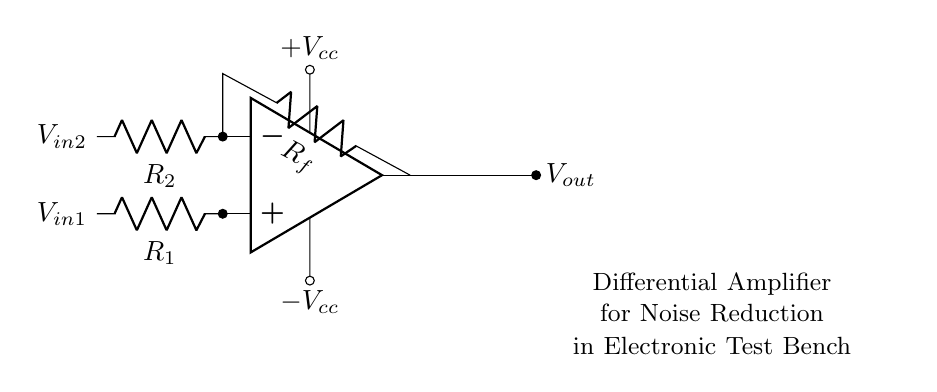What type of amplifier is shown in the circuit diagram? The circuit diagram indicates a differential amplifier, which is characterized by its two input signals and the configuration of its components.
Answer: Differential amplifier What are the resistances labeled in the circuit? The resistances in the circuit are labeled as R1, R2, and Rf. R1 and R2 are input resistors, while Rf is the feedback resistor, connected from the output back to the inverting input.
Answer: R1, R2, Rf What is the function of the feedback resistor Rf? The feedback resistor Rf is used to control the gain of the amplifier by providing a feedback loop that determines how much of the output voltage is fed back to the inverting input, stabilizing the circuit and setting the gain equation.
Answer: Control gain What voltage levels are indicated for the operational amplifier? The operational amplifier has voltage levels indicated as +Vcc for the positive supply and -Vcc for the negative supply, providing the necessary power for its operation.
Answer: +Vcc, -Vcc How does the amplifier reduce noise? The amplifier reduces noise by amplifying the difference between the two input signals (V_in1 and V_in2), which effectively cancels out common-mode noise present in both signals, allowing only the desired differential signal to be amplified.
Answer: Cancels common-mode noise What will happen if R1 and R2 are equal? If R1 and R2 are equal, the differential amplifier will produce a gain of one for the differential input, meaning the output voltage will closely reflect the difference between the inputs without amplifying them, as the resistor values determine the gain ratio.
Answer: Gain of one What are the input signals for the amplifier shown? The input signals for the amplifier are labeled as V_in1 and V_in2, with V_in1 connected to the non-inverting input and V_in2 connected to the inverting input of the operational amplifier.
Answer: V_in1, V_in2 